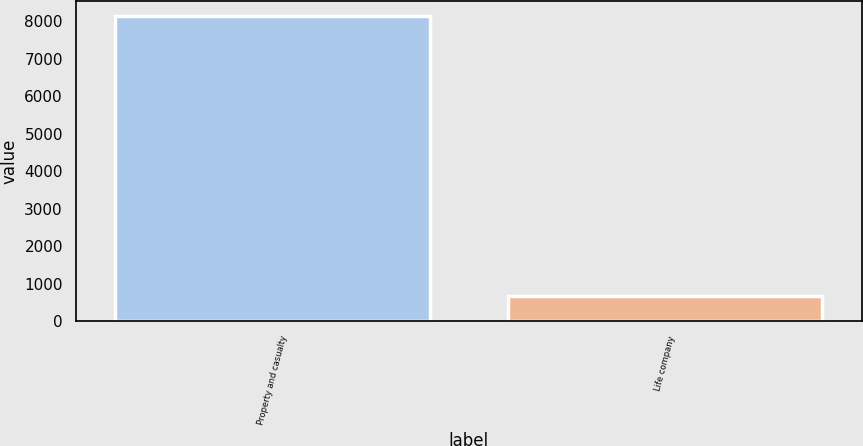<chart> <loc_0><loc_0><loc_500><loc_500><bar_chart><fcel>Property and casualty<fcel>Life company<nl><fcel>8137<fcel>687<nl></chart> 